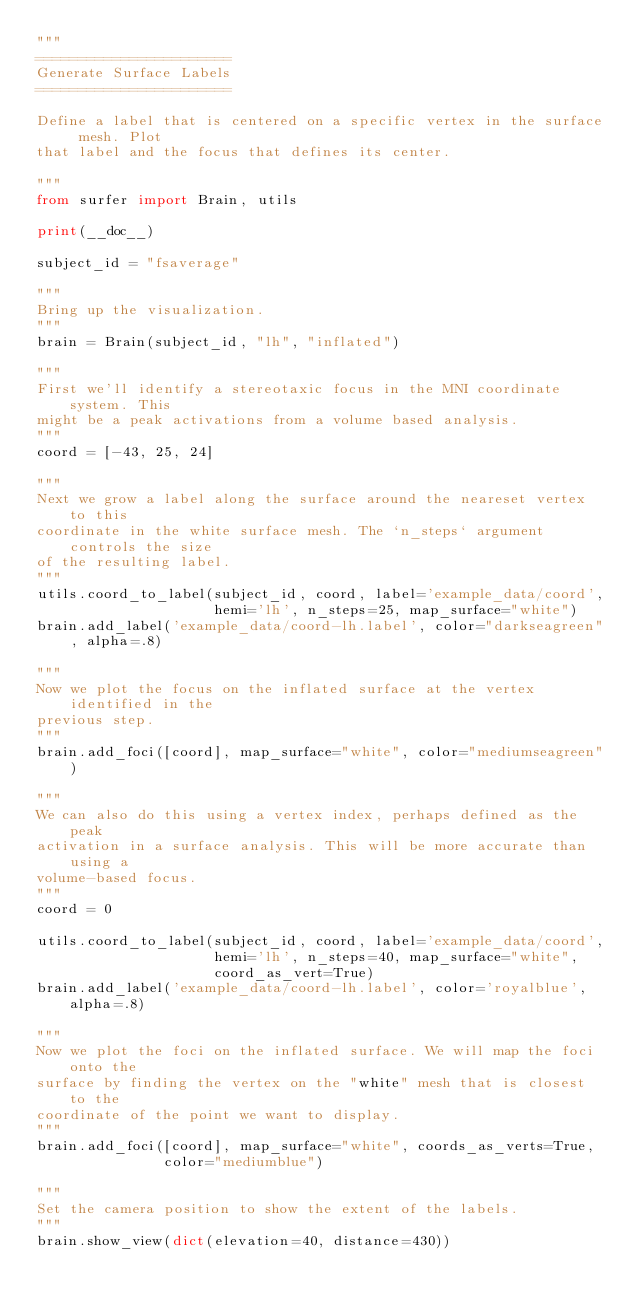<code> <loc_0><loc_0><loc_500><loc_500><_Python_>"""
=======================
Generate Surface Labels
=======================

Define a label that is centered on a specific vertex in the surface mesh. Plot
that label and the focus that defines its center.

"""
from surfer import Brain, utils

print(__doc__)

subject_id = "fsaverage"

"""
Bring up the visualization.
"""
brain = Brain(subject_id, "lh", "inflated")

"""
First we'll identify a stereotaxic focus in the MNI coordinate system. This
might be a peak activations from a volume based analysis.
"""
coord = [-43, 25, 24]

"""
Next we grow a label along the surface around the neareset vertex to this
coordinate in the white surface mesh. The `n_steps` argument controls the size
of the resulting label.
"""
utils.coord_to_label(subject_id, coord, label='example_data/coord',
                     hemi='lh', n_steps=25, map_surface="white")
brain.add_label('example_data/coord-lh.label', color="darkseagreen", alpha=.8)

"""
Now we plot the focus on the inflated surface at the vertex identified in the
previous step.
"""
brain.add_foci([coord], map_surface="white", color="mediumseagreen")

"""
We can also do this using a vertex index, perhaps defined as the peak
activation in a surface analysis. This will be more accurate than using a
volume-based focus.
"""
coord = 0

utils.coord_to_label(subject_id, coord, label='example_data/coord',
                     hemi='lh', n_steps=40, map_surface="white",
                     coord_as_vert=True)
brain.add_label('example_data/coord-lh.label', color='royalblue', alpha=.8)

"""
Now we plot the foci on the inflated surface. We will map the foci onto the
surface by finding the vertex on the "white" mesh that is closest to the
coordinate of the point we want to display.
"""
brain.add_foci([coord], map_surface="white", coords_as_verts=True,
               color="mediumblue")

"""
Set the camera position to show the extent of the labels.
"""
brain.show_view(dict(elevation=40, distance=430))
</code> 